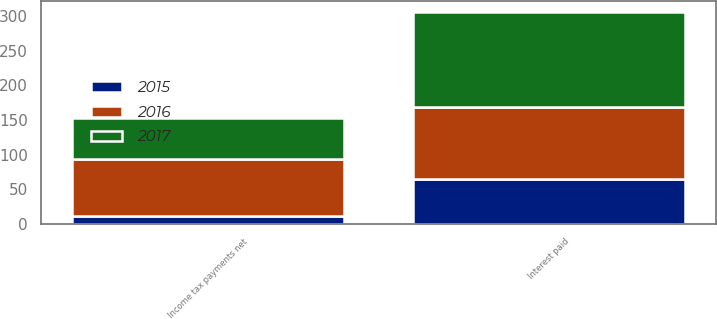Convert chart to OTSL. <chart><loc_0><loc_0><loc_500><loc_500><stacked_bar_chart><ecel><fcel>Interest paid<fcel>Income tax payments net<nl><fcel>2017<fcel>137.2<fcel>59.3<nl><fcel>2016<fcel>103<fcel>81.5<nl><fcel>2015<fcel>65.4<fcel>11.5<nl></chart> 